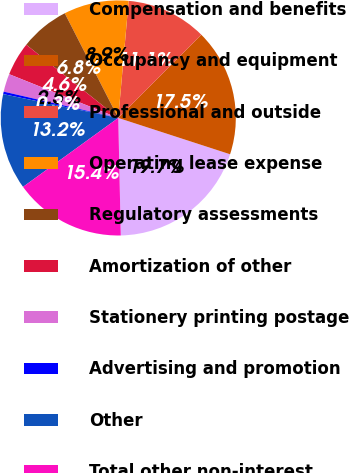Convert chart. <chart><loc_0><loc_0><loc_500><loc_500><pie_chart><fcel>Compensation and benefits<fcel>Occupancy and equipment<fcel>Professional and outside<fcel>Operating lease expense<fcel>Regulatory assessments<fcel>Amortization of other<fcel>Stationery printing postage<fcel>Advertising and promotion<fcel>Other<fcel>Total other non-interest<nl><fcel>19.66%<fcel>17.52%<fcel>11.07%<fcel>8.93%<fcel>6.78%<fcel>4.63%<fcel>2.48%<fcel>0.34%<fcel>13.22%<fcel>15.37%<nl></chart> 